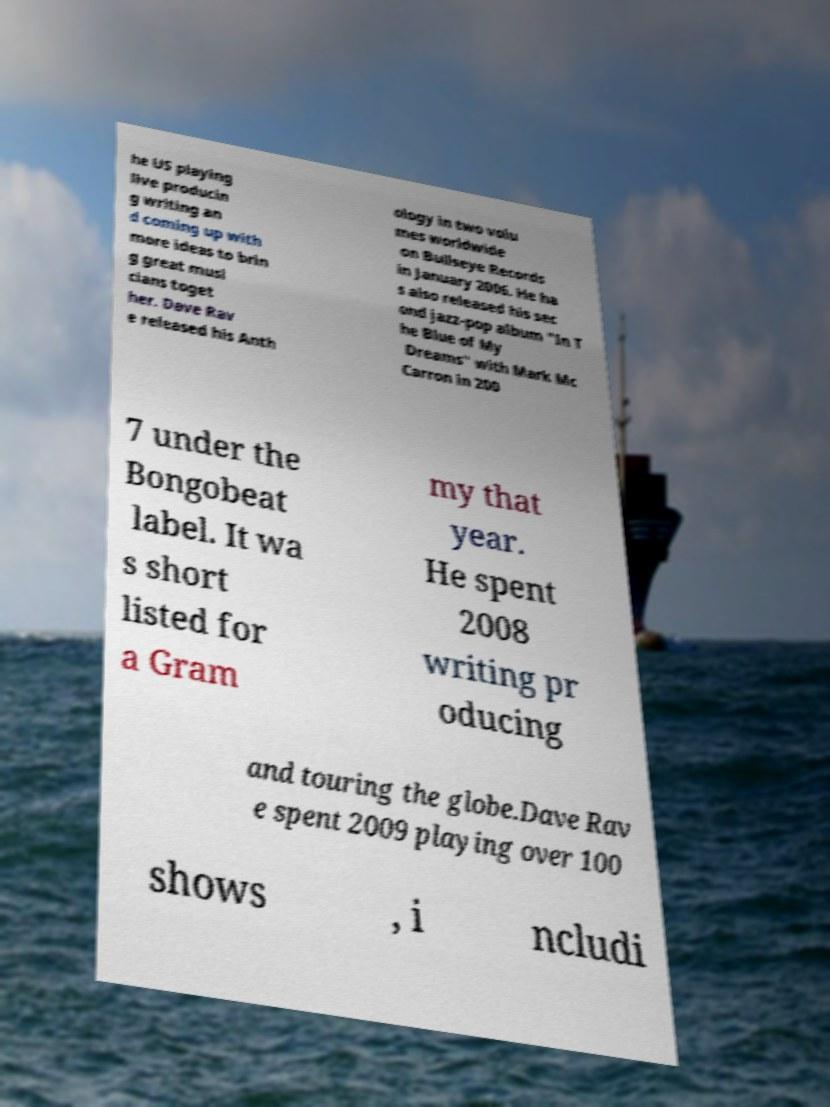Can you read and provide the text displayed in the image?This photo seems to have some interesting text. Can you extract and type it out for me? he US playing live producin g writing an d coming up with more ideas to brin g great musi cians toget her. Dave Rav e released his Anth ology in two volu mes worldwide on Bullseye Records in January 2006. He ha s also released his sec ond jazz-pop album "In T he Blue of My Dreams" with Mark Mc Carron in 200 7 under the Bongobeat label. It wa s short listed for a Gram my that year. He spent 2008 writing pr oducing and touring the globe.Dave Rav e spent 2009 playing over 100 shows , i ncludi 